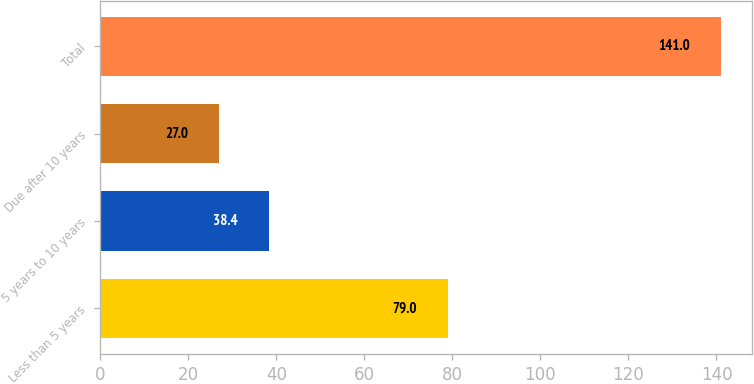Convert chart. <chart><loc_0><loc_0><loc_500><loc_500><bar_chart><fcel>Less than 5 years<fcel>5 years to 10 years<fcel>Due after 10 years<fcel>Total<nl><fcel>79<fcel>38.4<fcel>27<fcel>141<nl></chart> 